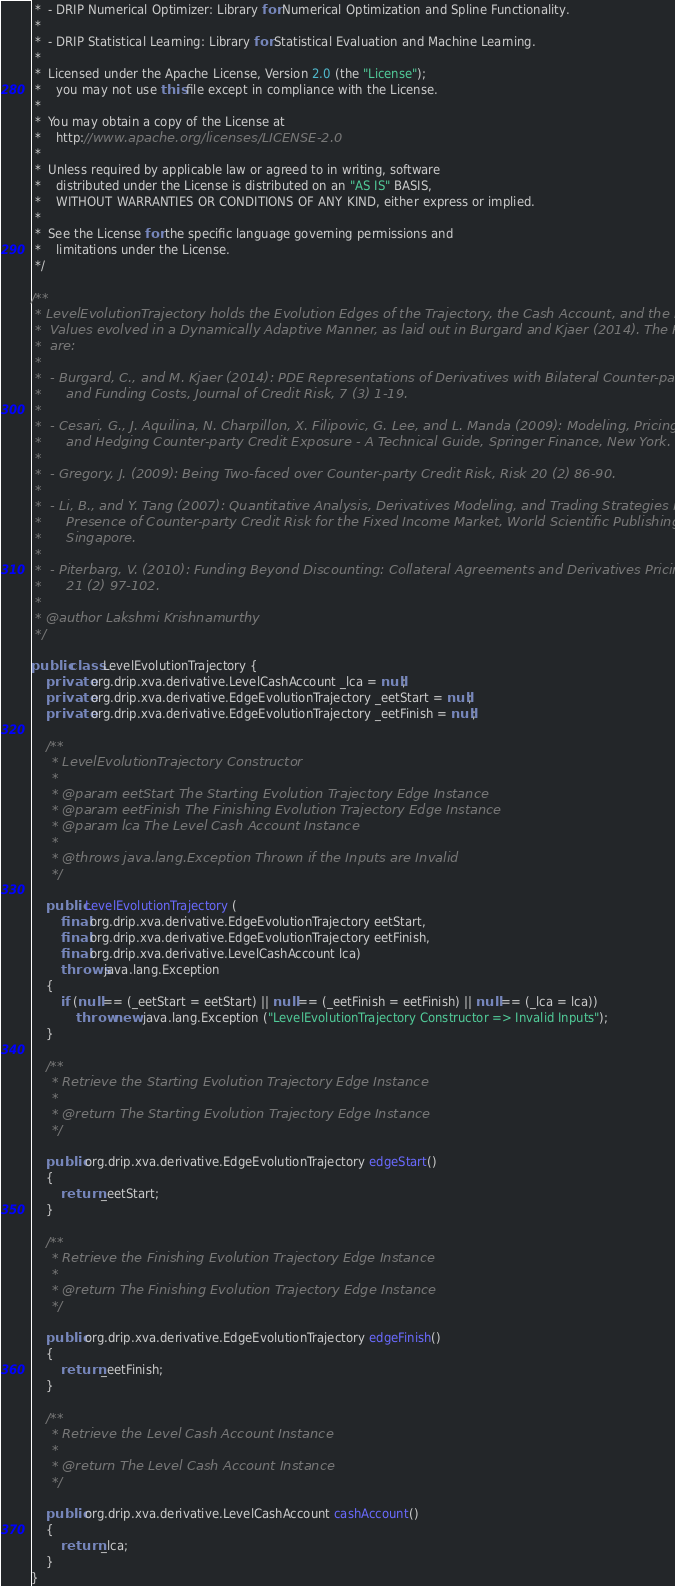<code> <loc_0><loc_0><loc_500><loc_500><_Java_> *  - DRIP Numerical Optimizer: Library for Numerical Optimization and Spline Functionality.
 * 
 *  - DRIP Statistical Learning: Library for Statistical Evaluation and Machine Learning.
 * 
 *  Licensed under the Apache License, Version 2.0 (the "License");
 *   	you may not use this file except in compliance with the License.
 *   
 *  You may obtain a copy of the License at
 *  	http://www.apache.org/licenses/LICENSE-2.0
 *  
 *  Unless required by applicable law or agreed to in writing, software
 *  	distributed under the License is distributed on an "AS IS" BASIS,
 *  	WITHOUT WARRANTIES OR CONDITIONS OF ANY KIND, either express or implied.
 *  
 *  See the License for the specific language governing permissions and
 *  	limitations under the License.
 */

/**
 * LevelEvolutionTrajectory holds the Evolution Edges of the Trajectory, the Cash Account, and the Derivative
 * 	Values evolved in a Dynamically Adaptive Manner, as laid out in Burgard and Kjaer (2014). The References
 *  are:
 *  
 *  - Burgard, C., and M. Kjaer (2014): PDE Representations of Derivatives with Bilateral Counter-party Risk
 *  	and Funding Costs, Journal of Credit Risk, 7 (3) 1-19.
 *  
 *  - Cesari, G., J. Aquilina, N. Charpillon, X. Filipovic, G. Lee, and L. Manda (2009): Modeling, Pricing,
 *  	and Hedging Counter-party Credit Exposure - A Technical Guide, Springer Finance, New York.
 *  
 *  - Gregory, J. (2009): Being Two-faced over Counter-party Credit Risk, Risk 20 (2) 86-90.
 *  
 *  - Li, B., and Y. Tang (2007): Quantitative Analysis, Derivatives Modeling, and Trading Strategies in the
 *  	Presence of Counter-party Credit Risk for the Fixed Income Market, World Scientific Publishing,
 *  	Singapore.
 * 
 *  - Piterbarg, V. (2010): Funding Beyond Discounting: Collateral Agreements and Derivatives Pricing, Risk
 *  	21 (2) 97-102.
 * 
 * @author Lakshmi Krishnamurthy
 */

public class LevelEvolutionTrajectory {
	private org.drip.xva.derivative.LevelCashAccount _lca = null;
	private org.drip.xva.derivative.EdgeEvolutionTrajectory _eetStart = null;
	private org.drip.xva.derivative.EdgeEvolutionTrajectory _eetFinish = null;

	/**
	 * LevelEvolutionTrajectory Constructor
	 * 
	 * @param eetStart The Starting Evolution Trajectory Edge Instance
	 * @param eetFinish The Finishing Evolution Trajectory Edge Instance
	 * @param lca The Level Cash Account Instance
	 * 
	 * @throws java.lang.Exception Thrown if the Inputs are Invalid
	 */

	public LevelEvolutionTrajectory (
		final org.drip.xva.derivative.EdgeEvolutionTrajectory eetStart,
		final org.drip.xva.derivative.EdgeEvolutionTrajectory eetFinish,
		final org.drip.xva.derivative.LevelCashAccount lca)
		throws java.lang.Exception
	{
		if (null == (_eetStart = eetStart) || null == (_eetFinish = eetFinish) || null == (_lca = lca))
			throw new java.lang.Exception ("LevelEvolutionTrajectory Constructor => Invalid Inputs");
	}

	/**
	 * Retrieve the Starting Evolution Trajectory Edge Instance
	 * 
	 * @return The Starting Evolution Trajectory Edge Instance
	 */

	public org.drip.xva.derivative.EdgeEvolutionTrajectory edgeStart()
	{
		return _eetStart;
	}

	/**
	 * Retrieve the Finishing Evolution Trajectory Edge Instance
	 * 
	 * @return The Finishing Evolution Trajectory Edge Instance
	 */

	public org.drip.xva.derivative.EdgeEvolutionTrajectory edgeFinish()
	{
		return _eetFinish;
	}

	/**
	 * Retrieve the Level Cash Account Instance
	 * 
	 * @return The Level Cash Account Instance
	 */

	public org.drip.xva.derivative.LevelCashAccount cashAccount()
	{
		return _lca;
	}
}
</code> 